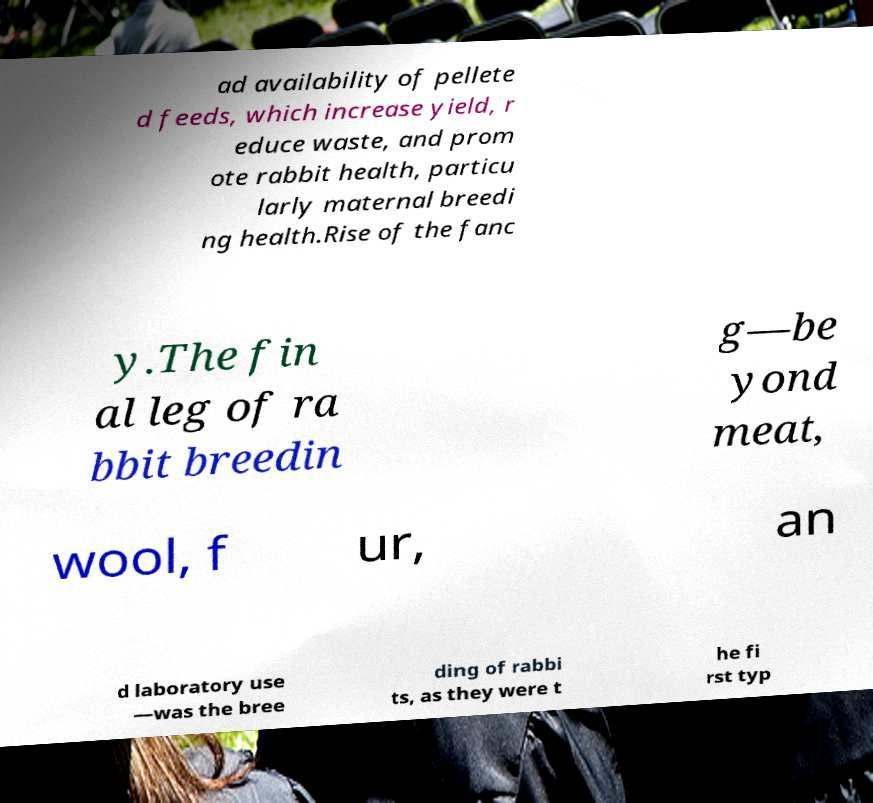What messages or text are displayed in this image? I need them in a readable, typed format. ad availability of pellete d feeds, which increase yield, r educe waste, and prom ote rabbit health, particu larly maternal breedi ng health.Rise of the fanc y.The fin al leg of ra bbit breedin g—be yond meat, wool, f ur, an d laboratory use —was the bree ding of rabbi ts, as they were t he fi rst typ 